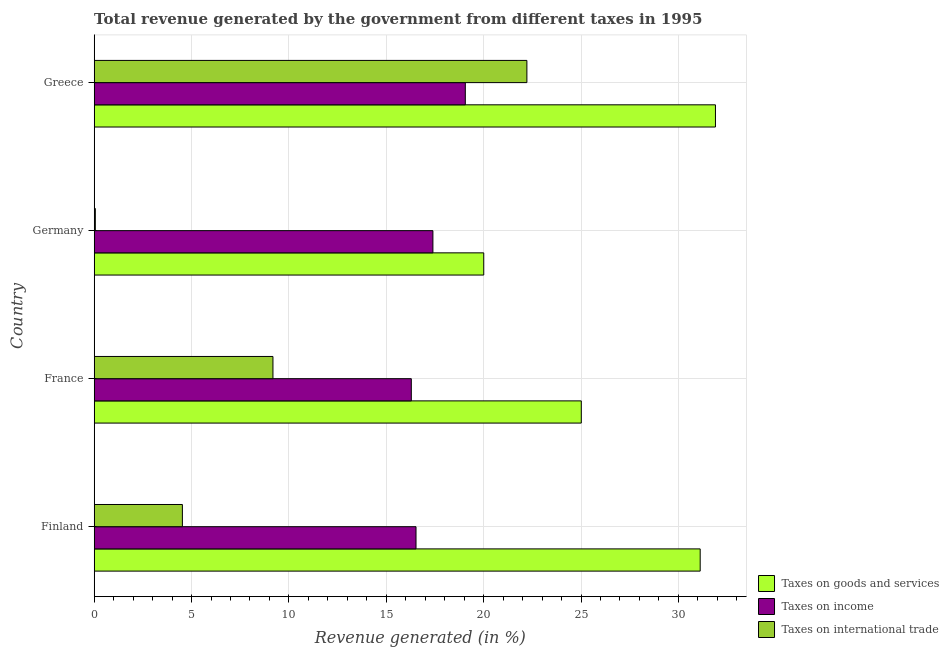How many groups of bars are there?
Give a very brief answer. 4. Are the number of bars on each tick of the Y-axis equal?
Offer a terse response. Yes. How many bars are there on the 1st tick from the top?
Provide a succinct answer. 3. How many bars are there on the 2nd tick from the bottom?
Keep it short and to the point. 3. What is the percentage of revenue generated by tax on international trade in Germany?
Your answer should be very brief. 0.06. Across all countries, what is the maximum percentage of revenue generated by taxes on goods and services?
Your answer should be very brief. 31.9. Across all countries, what is the minimum percentage of revenue generated by taxes on income?
Provide a succinct answer. 16.28. In which country was the percentage of revenue generated by taxes on income minimum?
Offer a terse response. France. What is the total percentage of revenue generated by taxes on goods and services in the graph?
Your answer should be very brief. 108.04. What is the difference between the percentage of revenue generated by tax on international trade in France and that in Germany?
Ensure brevity in your answer.  9.12. What is the difference between the percentage of revenue generated by taxes on goods and services in Germany and the percentage of revenue generated by taxes on income in Greece?
Keep it short and to the point. 0.95. What is the average percentage of revenue generated by taxes on income per country?
Provide a succinct answer. 17.32. What is the difference between the percentage of revenue generated by tax on international trade and percentage of revenue generated by taxes on income in Greece?
Your answer should be very brief. 3.16. In how many countries, is the percentage of revenue generated by tax on international trade greater than 18 %?
Your answer should be compact. 1. What is the ratio of the percentage of revenue generated by taxes on goods and services in Finland to that in France?
Your answer should be very brief. 1.24. What is the difference between the highest and the second highest percentage of revenue generated by taxes on goods and services?
Give a very brief answer. 0.78. What is the difference between the highest and the lowest percentage of revenue generated by tax on international trade?
Keep it short and to the point. 22.16. Is the sum of the percentage of revenue generated by tax on international trade in France and Greece greater than the maximum percentage of revenue generated by taxes on goods and services across all countries?
Offer a very short reply. No. What does the 1st bar from the top in Germany represents?
Keep it short and to the point. Taxes on international trade. What does the 2nd bar from the bottom in France represents?
Your answer should be very brief. Taxes on income. Are all the bars in the graph horizontal?
Provide a succinct answer. Yes. How many countries are there in the graph?
Give a very brief answer. 4. Are the values on the major ticks of X-axis written in scientific E-notation?
Make the answer very short. No. Does the graph contain any zero values?
Give a very brief answer. No. Where does the legend appear in the graph?
Your answer should be compact. Bottom right. How are the legend labels stacked?
Give a very brief answer. Vertical. What is the title of the graph?
Ensure brevity in your answer.  Total revenue generated by the government from different taxes in 1995. What is the label or title of the X-axis?
Your answer should be compact. Revenue generated (in %). What is the label or title of the Y-axis?
Provide a short and direct response. Country. What is the Revenue generated (in %) in Taxes on goods and services in Finland?
Your response must be concise. 31.12. What is the Revenue generated (in %) in Taxes on income in Finland?
Keep it short and to the point. 16.53. What is the Revenue generated (in %) in Taxes on international trade in Finland?
Offer a very short reply. 4.53. What is the Revenue generated (in %) in Taxes on goods and services in France?
Give a very brief answer. 25.01. What is the Revenue generated (in %) in Taxes on income in France?
Your answer should be compact. 16.28. What is the Revenue generated (in %) in Taxes on international trade in France?
Offer a very short reply. 9.18. What is the Revenue generated (in %) of Taxes on goods and services in Germany?
Offer a terse response. 20. What is the Revenue generated (in %) of Taxes on income in Germany?
Your answer should be very brief. 17.39. What is the Revenue generated (in %) of Taxes on international trade in Germany?
Your response must be concise. 0.06. What is the Revenue generated (in %) in Taxes on goods and services in Greece?
Offer a terse response. 31.9. What is the Revenue generated (in %) in Taxes on income in Greece?
Provide a short and direct response. 19.06. What is the Revenue generated (in %) in Taxes on international trade in Greece?
Provide a succinct answer. 22.22. Across all countries, what is the maximum Revenue generated (in %) in Taxes on goods and services?
Give a very brief answer. 31.9. Across all countries, what is the maximum Revenue generated (in %) of Taxes on income?
Provide a succinct answer. 19.06. Across all countries, what is the maximum Revenue generated (in %) in Taxes on international trade?
Make the answer very short. 22.22. Across all countries, what is the minimum Revenue generated (in %) of Taxes on goods and services?
Provide a short and direct response. 20. Across all countries, what is the minimum Revenue generated (in %) in Taxes on income?
Offer a terse response. 16.28. Across all countries, what is the minimum Revenue generated (in %) in Taxes on international trade?
Ensure brevity in your answer.  0.06. What is the total Revenue generated (in %) of Taxes on goods and services in the graph?
Ensure brevity in your answer.  108.04. What is the total Revenue generated (in %) in Taxes on income in the graph?
Provide a succinct answer. 69.26. What is the total Revenue generated (in %) of Taxes on international trade in the graph?
Keep it short and to the point. 35.99. What is the difference between the Revenue generated (in %) of Taxes on goods and services in Finland and that in France?
Your answer should be very brief. 6.11. What is the difference between the Revenue generated (in %) in Taxes on income in Finland and that in France?
Your answer should be compact. 0.24. What is the difference between the Revenue generated (in %) in Taxes on international trade in Finland and that in France?
Keep it short and to the point. -4.65. What is the difference between the Revenue generated (in %) of Taxes on goods and services in Finland and that in Germany?
Your answer should be compact. 11.11. What is the difference between the Revenue generated (in %) of Taxes on income in Finland and that in Germany?
Offer a terse response. -0.87. What is the difference between the Revenue generated (in %) of Taxes on international trade in Finland and that in Germany?
Give a very brief answer. 4.47. What is the difference between the Revenue generated (in %) of Taxes on goods and services in Finland and that in Greece?
Your answer should be very brief. -0.78. What is the difference between the Revenue generated (in %) of Taxes on income in Finland and that in Greece?
Provide a succinct answer. -2.53. What is the difference between the Revenue generated (in %) of Taxes on international trade in Finland and that in Greece?
Provide a succinct answer. -17.69. What is the difference between the Revenue generated (in %) of Taxes on goods and services in France and that in Germany?
Offer a very short reply. 5.01. What is the difference between the Revenue generated (in %) in Taxes on income in France and that in Germany?
Offer a terse response. -1.11. What is the difference between the Revenue generated (in %) of Taxes on international trade in France and that in Germany?
Give a very brief answer. 9.12. What is the difference between the Revenue generated (in %) in Taxes on goods and services in France and that in Greece?
Your answer should be very brief. -6.89. What is the difference between the Revenue generated (in %) in Taxes on income in France and that in Greece?
Provide a short and direct response. -2.77. What is the difference between the Revenue generated (in %) in Taxes on international trade in France and that in Greece?
Keep it short and to the point. -13.04. What is the difference between the Revenue generated (in %) of Taxes on goods and services in Germany and that in Greece?
Make the answer very short. -11.9. What is the difference between the Revenue generated (in %) in Taxes on income in Germany and that in Greece?
Make the answer very short. -1.66. What is the difference between the Revenue generated (in %) in Taxes on international trade in Germany and that in Greece?
Provide a short and direct response. -22.16. What is the difference between the Revenue generated (in %) of Taxes on goods and services in Finland and the Revenue generated (in %) of Taxes on income in France?
Offer a terse response. 14.83. What is the difference between the Revenue generated (in %) of Taxes on goods and services in Finland and the Revenue generated (in %) of Taxes on international trade in France?
Ensure brevity in your answer.  21.94. What is the difference between the Revenue generated (in %) of Taxes on income in Finland and the Revenue generated (in %) of Taxes on international trade in France?
Give a very brief answer. 7.35. What is the difference between the Revenue generated (in %) of Taxes on goods and services in Finland and the Revenue generated (in %) of Taxes on income in Germany?
Your answer should be very brief. 13.73. What is the difference between the Revenue generated (in %) in Taxes on goods and services in Finland and the Revenue generated (in %) in Taxes on international trade in Germany?
Offer a terse response. 31.06. What is the difference between the Revenue generated (in %) in Taxes on income in Finland and the Revenue generated (in %) in Taxes on international trade in Germany?
Ensure brevity in your answer.  16.47. What is the difference between the Revenue generated (in %) in Taxes on goods and services in Finland and the Revenue generated (in %) in Taxes on income in Greece?
Your answer should be very brief. 12.06. What is the difference between the Revenue generated (in %) in Taxes on goods and services in Finland and the Revenue generated (in %) in Taxes on international trade in Greece?
Offer a very short reply. 8.9. What is the difference between the Revenue generated (in %) in Taxes on income in Finland and the Revenue generated (in %) in Taxes on international trade in Greece?
Your response must be concise. -5.69. What is the difference between the Revenue generated (in %) of Taxes on goods and services in France and the Revenue generated (in %) of Taxes on income in Germany?
Offer a terse response. 7.62. What is the difference between the Revenue generated (in %) of Taxes on goods and services in France and the Revenue generated (in %) of Taxes on international trade in Germany?
Your response must be concise. 24.96. What is the difference between the Revenue generated (in %) of Taxes on income in France and the Revenue generated (in %) of Taxes on international trade in Germany?
Provide a short and direct response. 16.23. What is the difference between the Revenue generated (in %) of Taxes on goods and services in France and the Revenue generated (in %) of Taxes on income in Greece?
Make the answer very short. 5.96. What is the difference between the Revenue generated (in %) of Taxes on goods and services in France and the Revenue generated (in %) of Taxes on international trade in Greece?
Your answer should be very brief. 2.79. What is the difference between the Revenue generated (in %) of Taxes on income in France and the Revenue generated (in %) of Taxes on international trade in Greece?
Your response must be concise. -5.94. What is the difference between the Revenue generated (in %) in Taxes on goods and services in Germany and the Revenue generated (in %) in Taxes on income in Greece?
Offer a very short reply. 0.95. What is the difference between the Revenue generated (in %) of Taxes on goods and services in Germany and the Revenue generated (in %) of Taxes on international trade in Greece?
Give a very brief answer. -2.22. What is the difference between the Revenue generated (in %) of Taxes on income in Germany and the Revenue generated (in %) of Taxes on international trade in Greece?
Provide a short and direct response. -4.83. What is the average Revenue generated (in %) of Taxes on goods and services per country?
Keep it short and to the point. 27.01. What is the average Revenue generated (in %) in Taxes on income per country?
Give a very brief answer. 17.32. What is the average Revenue generated (in %) in Taxes on international trade per country?
Your answer should be compact. 9. What is the difference between the Revenue generated (in %) in Taxes on goods and services and Revenue generated (in %) in Taxes on income in Finland?
Give a very brief answer. 14.59. What is the difference between the Revenue generated (in %) in Taxes on goods and services and Revenue generated (in %) in Taxes on international trade in Finland?
Your answer should be very brief. 26.59. What is the difference between the Revenue generated (in %) in Taxes on income and Revenue generated (in %) in Taxes on international trade in Finland?
Keep it short and to the point. 12. What is the difference between the Revenue generated (in %) in Taxes on goods and services and Revenue generated (in %) in Taxes on income in France?
Give a very brief answer. 8.73. What is the difference between the Revenue generated (in %) in Taxes on goods and services and Revenue generated (in %) in Taxes on international trade in France?
Your answer should be very brief. 15.83. What is the difference between the Revenue generated (in %) of Taxes on income and Revenue generated (in %) of Taxes on international trade in France?
Keep it short and to the point. 7.1. What is the difference between the Revenue generated (in %) in Taxes on goods and services and Revenue generated (in %) in Taxes on income in Germany?
Provide a succinct answer. 2.61. What is the difference between the Revenue generated (in %) in Taxes on goods and services and Revenue generated (in %) in Taxes on international trade in Germany?
Provide a succinct answer. 19.95. What is the difference between the Revenue generated (in %) of Taxes on income and Revenue generated (in %) of Taxes on international trade in Germany?
Provide a short and direct response. 17.34. What is the difference between the Revenue generated (in %) in Taxes on goods and services and Revenue generated (in %) in Taxes on income in Greece?
Ensure brevity in your answer.  12.85. What is the difference between the Revenue generated (in %) of Taxes on goods and services and Revenue generated (in %) of Taxes on international trade in Greece?
Give a very brief answer. 9.68. What is the difference between the Revenue generated (in %) of Taxes on income and Revenue generated (in %) of Taxes on international trade in Greece?
Offer a very short reply. -3.16. What is the ratio of the Revenue generated (in %) of Taxes on goods and services in Finland to that in France?
Offer a terse response. 1.24. What is the ratio of the Revenue generated (in %) of Taxes on income in Finland to that in France?
Provide a short and direct response. 1.01. What is the ratio of the Revenue generated (in %) in Taxes on international trade in Finland to that in France?
Provide a short and direct response. 0.49. What is the ratio of the Revenue generated (in %) in Taxes on goods and services in Finland to that in Germany?
Give a very brief answer. 1.56. What is the ratio of the Revenue generated (in %) of Taxes on income in Finland to that in Germany?
Make the answer very short. 0.95. What is the ratio of the Revenue generated (in %) in Taxes on international trade in Finland to that in Germany?
Your response must be concise. 77.75. What is the ratio of the Revenue generated (in %) of Taxes on goods and services in Finland to that in Greece?
Offer a terse response. 0.98. What is the ratio of the Revenue generated (in %) in Taxes on income in Finland to that in Greece?
Make the answer very short. 0.87. What is the ratio of the Revenue generated (in %) in Taxes on international trade in Finland to that in Greece?
Make the answer very short. 0.2. What is the ratio of the Revenue generated (in %) of Taxes on goods and services in France to that in Germany?
Give a very brief answer. 1.25. What is the ratio of the Revenue generated (in %) in Taxes on income in France to that in Germany?
Make the answer very short. 0.94. What is the ratio of the Revenue generated (in %) in Taxes on international trade in France to that in Germany?
Give a very brief answer. 157.6. What is the ratio of the Revenue generated (in %) of Taxes on goods and services in France to that in Greece?
Your answer should be very brief. 0.78. What is the ratio of the Revenue generated (in %) of Taxes on income in France to that in Greece?
Make the answer very short. 0.85. What is the ratio of the Revenue generated (in %) of Taxes on international trade in France to that in Greece?
Ensure brevity in your answer.  0.41. What is the ratio of the Revenue generated (in %) in Taxes on goods and services in Germany to that in Greece?
Offer a terse response. 0.63. What is the ratio of the Revenue generated (in %) in Taxes on income in Germany to that in Greece?
Provide a short and direct response. 0.91. What is the ratio of the Revenue generated (in %) of Taxes on international trade in Germany to that in Greece?
Provide a succinct answer. 0. What is the difference between the highest and the second highest Revenue generated (in %) of Taxes on goods and services?
Provide a short and direct response. 0.78. What is the difference between the highest and the second highest Revenue generated (in %) in Taxes on income?
Ensure brevity in your answer.  1.66. What is the difference between the highest and the second highest Revenue generated (in %) in Taxes on international trade?
Your answer should be compact. 13.04. What is the difference between the highest and the lowest Revenue generated (in %) of Taxes on goods and services?
Your answer should be very brief. 11.9. What is the difference between the highest and the lowest Revenue generated (in %) of Taxes on income?
Give a very brief answer. 2.77. What is the difference between the highest and the lowest Revenue generated (in %) in Taxes on international trade?
Offer a terse response. 22.16. 